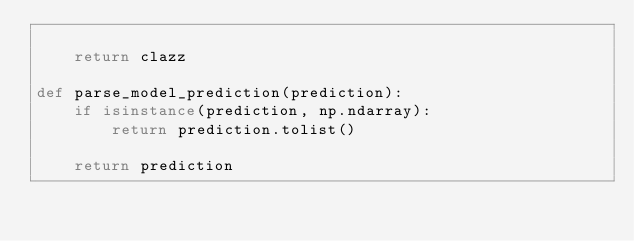Convert code to text. <code><loc_0><loc_0><loc_500><loc_500><_Python_>
    return clazz
    
def parse_model_prediction(prediction):
    if isinstance(prediction, np.ndarray):
        return prediction.tolist()

    return prediction</code> 